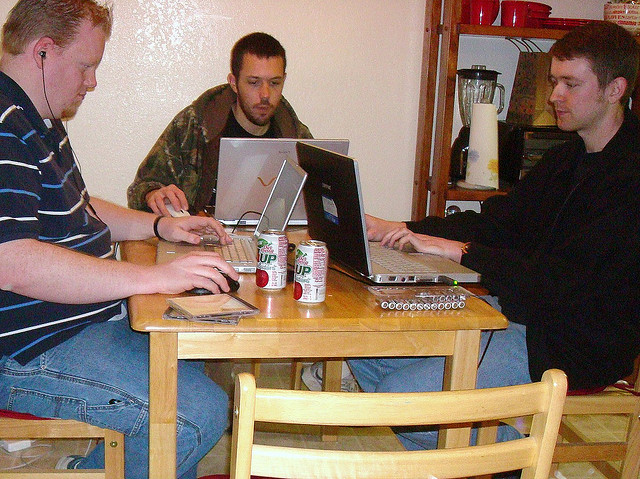Identify the text displayed in this image. UP UP 